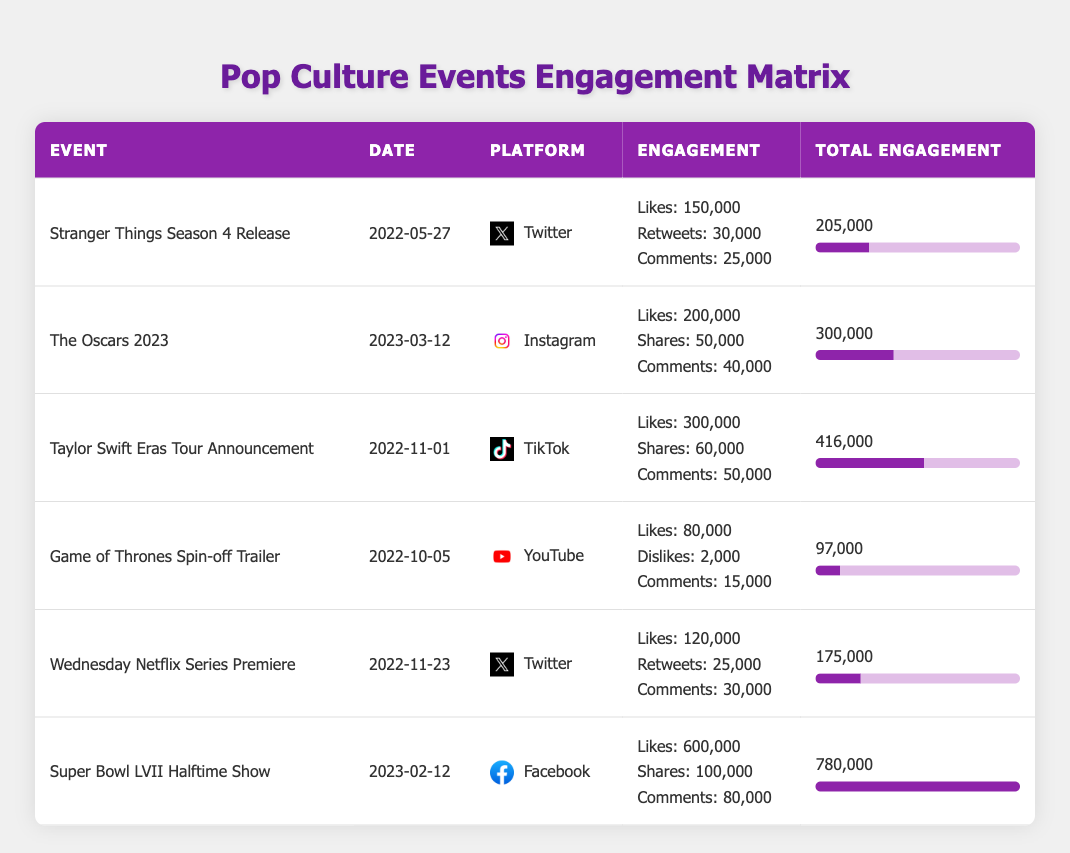What is the total engagement for the Super Bowl LVII Halftime Show? The table shows that the Super Bowl LVII Halftime Show has a total engagement of 780,000.
Answer: 780,000 Which event had the highest number of likes on social media? The Taylor Swift Eras Tour Announcement had the highest number of likes, totaling 300,000 as shown in the table.
Answer: 300,000 Did "Game of Thrones Spin-off Trailer" have more engagements than "Wednesday Netflix Series Premiere"? The total engagement for the Game of Thrones Spin-off Trailer is 97,000, while Wednesday Netflix Series Premiere has 175,000, so it did not have more engagements.
Answer: No What is the average total engagement of all the events listed in the table? To find the average, sum the total engagements: 205,000 + 300,000 + 416,000 + 97,000 + 175,000 + 780,000 = 2,073,000. Then divide by the number of events (6): 2,073,000 / 6 = 345,500.
Answer: 345,500 Is it true that the Oscars 2023 received more total engagement than the Stranger Things Season 4 Release? The Oscars 2023 had a total engagement of 300,000, while Stranger Things Season 4 Release had 205,000, which confirms that it did receive more engagement.
Answer: Yes How many comments did the Taylor Swift Eras Tour Announcement receive? The table indicates that the Taylor Swift Eras Tour Announcement received 50,000 comments.
Answer: 50,000 Which platform had the highest total engagement and what was that figure? The platform with the highest total engagement is Facebook, associated with the Super Bowl LVII Halftime Show, totaling 780,000.
Answer: Facebook, 780,000 What is the difference in total engagement between the Oscars 2023 and the Game of Thrones Spin-off Trailer? The total engagement for the Oscars 2023 is 300,000, and for the Game of Thrones Spin-off Trailer, it is 97,000. The difference is 300,000 - 97,000 = 203,000.
Answer: 203,000 Did the "Wednesday Netflix Series Premiere" generate more engagement than the "Stranger Things Season 4 Release" and by how much? Wednesday Netflix Series Premiere has 175,000 total engagement and Stranger Things Season 4 Release has 205,000. The difference is 205,000 - 175,000 = 30,000, meaning it generated less engagement.
Answer: No, by 30,000 